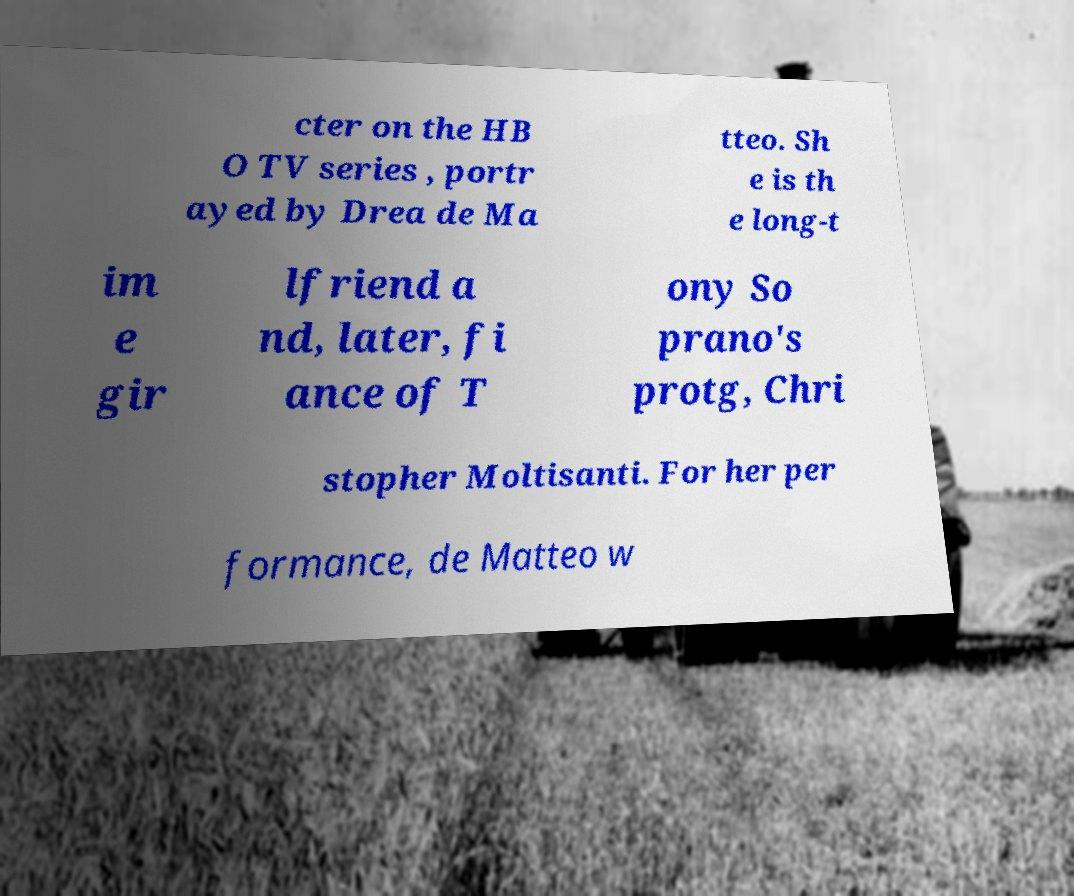I need the written content from this picture converted into text. Can you do that? cter on the HB O TV series , portr ayed by Drea de Ma tteo. Sh e is th e long-t im e gir lfriend a nd, later, fi ance of T ony So prano's protg, Chri stopher Moltisanti. For her per formance, de Matteo w 